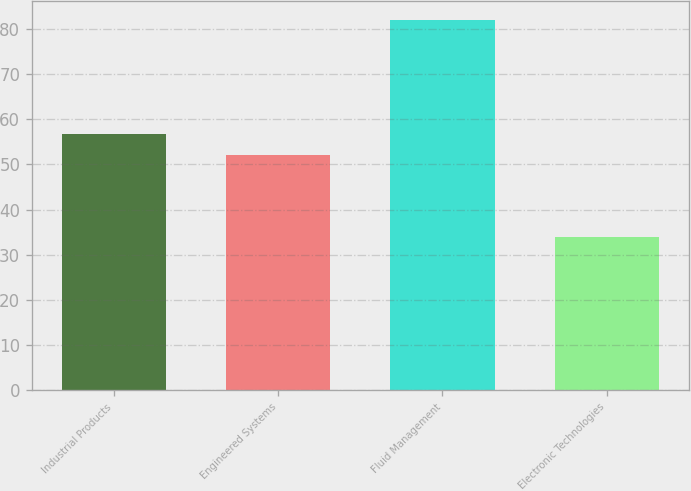Convert chart to OTSL. <chart><loc_0><loc_0><loc_500><loc_500><bar_chart><fcel>Industrial Products<fcel>Engineered Systems<fcel>Fluid Management<fcel>Electronic Technologies<nl><fcel>56.8<fcel>52<fcel>82<fcel>34<nl></chart> 